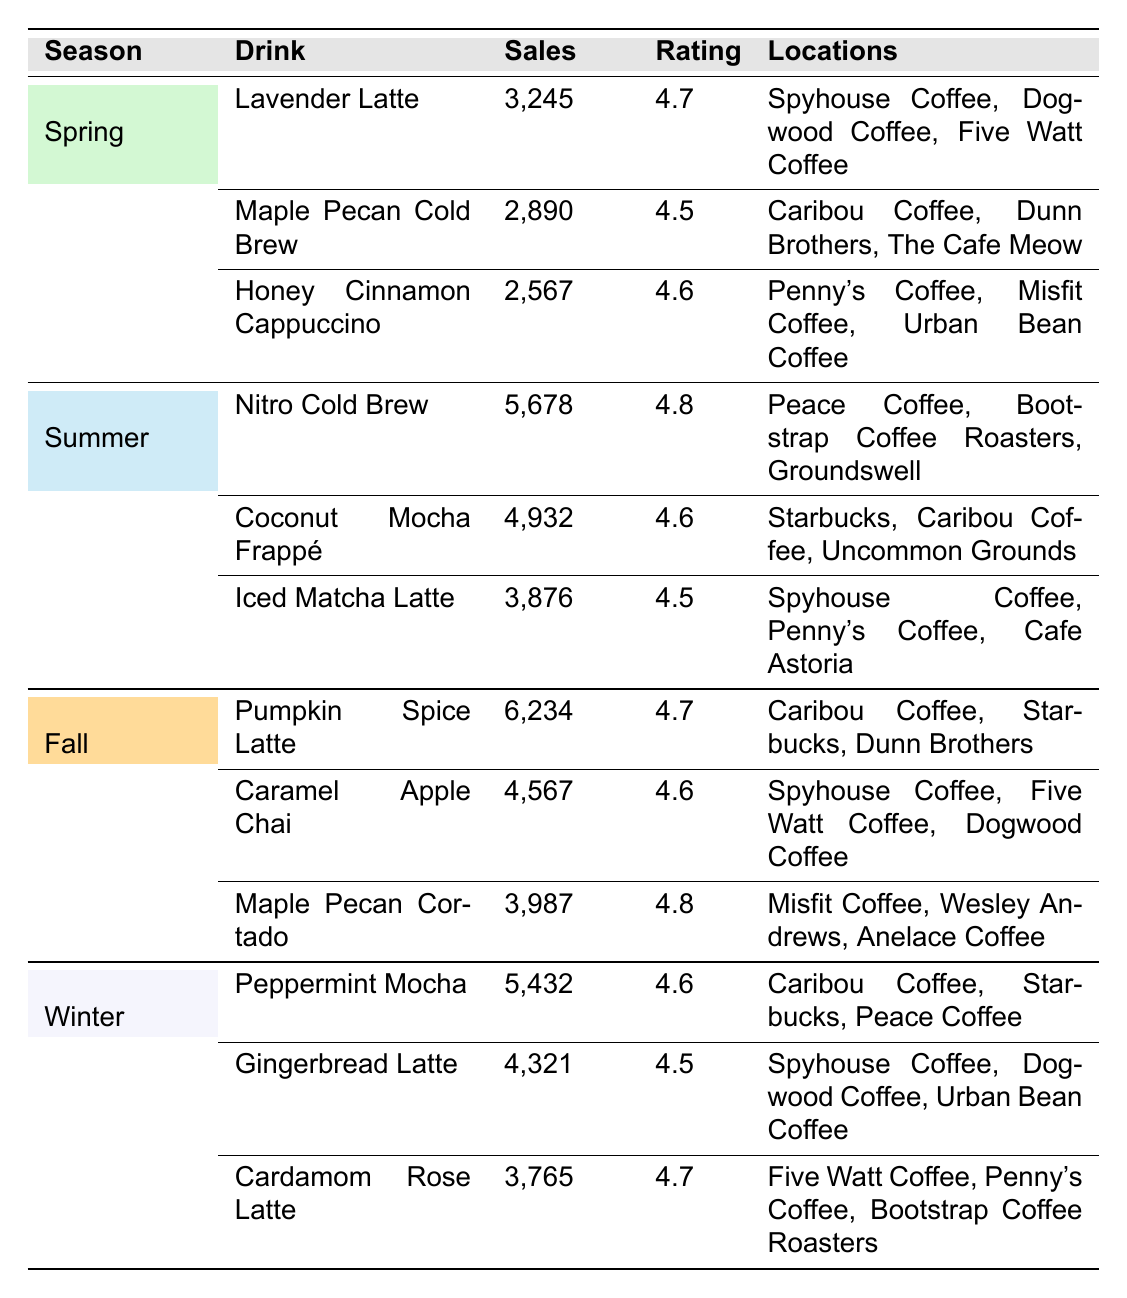What is the top-selling coffee drink in Fall? The table shows that the top-selling drink in Fall is the Pumpkin Spice Latte with 6,234 sales.
Answer: Pumpkin Spice Latte Which season had the highest-rated drink? By comparing the ratings, the Nitro Cold Brew during Summer has the highest rating of 4.8.
Answer: Summer What is the average sales of the top drinks in Winter? To calculate the average sales in Winter, I sum the sales: 5,432 + 4,321 + 3,765 = 13,518. Then I divide by the number of drinks (3): 13,518 / 3 = 4,506.
Answer: 4,506 Did any drink have a rating of 4.8? Yes, the Maple Pecan Cortado and Nitro Cold Brew both have a rating of 4.8 in Fall and Summer respectively.
Answer: Yes Which drink had the least sales in Spring? The Honey Cinnamon Cappuccino had the least sales in Spring with 2,567.
Answer: Honey Cinnamon Cappuccino How many drinks in Summer had sales above 4,000? In Summer, there are two drinks with sales above 4,000: Nitro Cold Brew (5,678) and Coconut Mocha Frappé (4,932).
Answer: 2 What is the difference in sales between the top drink in Winter and the top drink in Spring? The top drink in Winter is Peppermint Mocha with 5,432 sales and in Spring it is Lavender Latte with 3,245 sales. The difference is 5,432 - 3,245 = 2,187.
Answer: 2,187 Which locations serve the Honey Cinnamon Cappuccino? The Honey Cinnamon Cappuccino is served at Penny's Coffee, Misfit Coffee, and Urban Bean Coffee.
Answer: Penny's Coffee, Misfit Coffee, Urban Bean Coffee Are any drinks popular enough to sell over 6,000 times? Yes, the Pumpkin Spice Latte is the only drink that sold over 6,000 times, selling 6,234 times in Fall.
Answer: Yes What was the total sales for the top drinks in Spring? The total sales for Spring are 3,245 + 2,890 + 2,567 = 8,702.
Answer: 8,702 